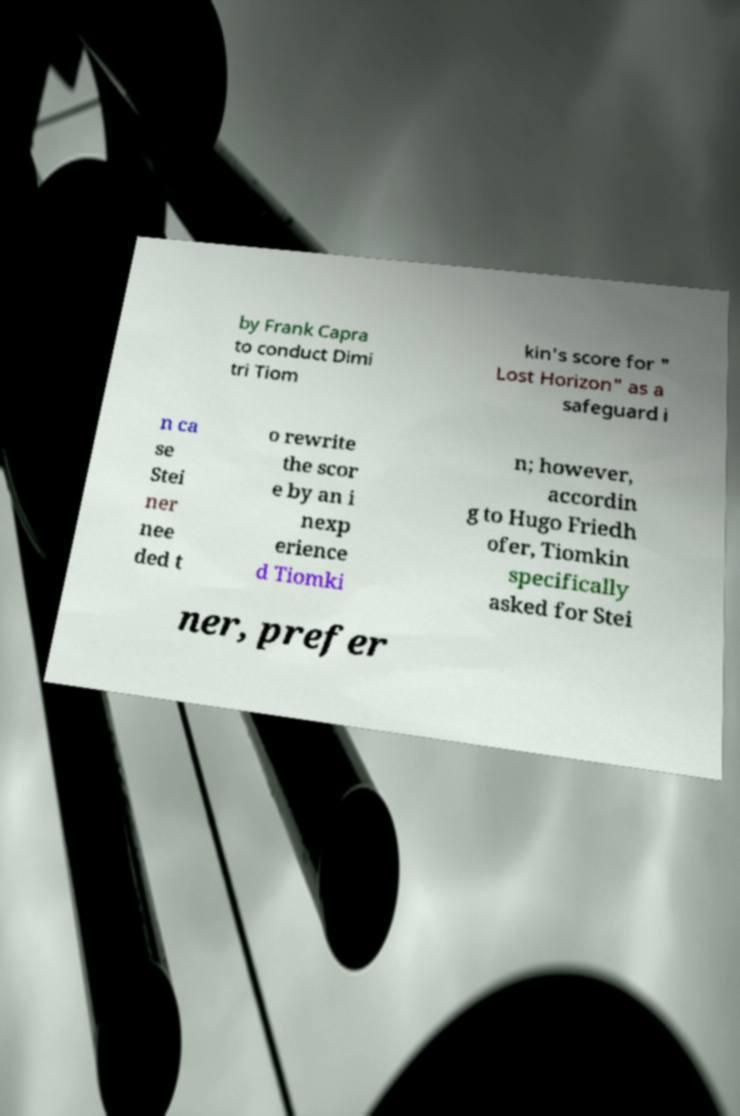I need the written content from this picture converted into text. Can you do that? by Frank Capra to conduct Dimi tri Tiom kin's score for " Lost Horizon" as a safeguard i n ca se Stei ner nee ded t o rewrite the scor e by an i nexp erience d Tiomki n; however, accordin g to Hugo Friedh ofer, Tiomkin specifically asked for Stei ner, prefer 